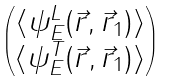<formula> <loc_0><loc_0><loc_500><loc_500>\begin{pmatrix} \langle \psi ^ { L } _ { E } ( \vec { r } , \vec { r } _ { 1 } ) \rangle \\ \langle \psi ^ { T } _ { E } ( \vec { r } , \vec { r } _ { 1 } ) \rangle \end{pmatrix}</formula> 